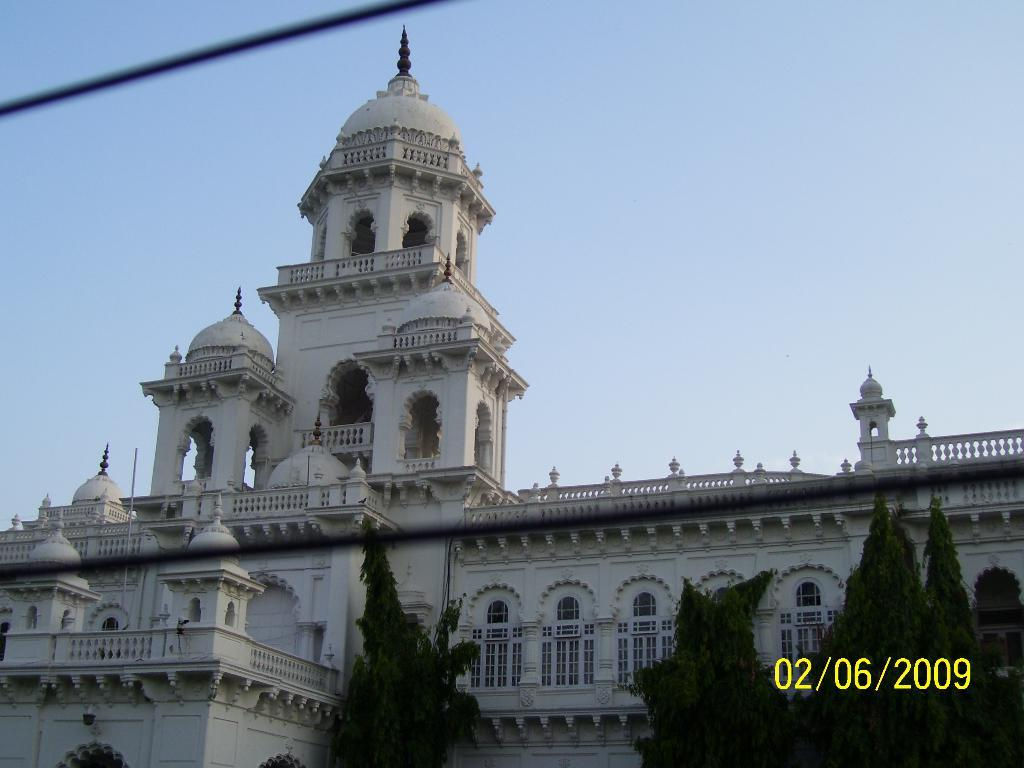What type of structure is present in the image? There is a building in the image. What feature of the building is mentioned in the facts? The building has doors. What can be seen in front of the building? There are trees in front of the building. What is visible in the background of the image? The sky is visible in the background of the image. What type of guitar can be seen hanging from the bridge in the image? There is no guitar or bridge present in the image. 